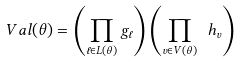<formula> <loc_0><loc_0><loc_500><loc_500>\ V a l ( \theta ) = \left ( \prod _ { \ell \in L ( \theta ) } g _ { \ell } \right ) \left ( \prod _ { v \in V ( \theta ) } \ h _ { v } \right )</formula> 